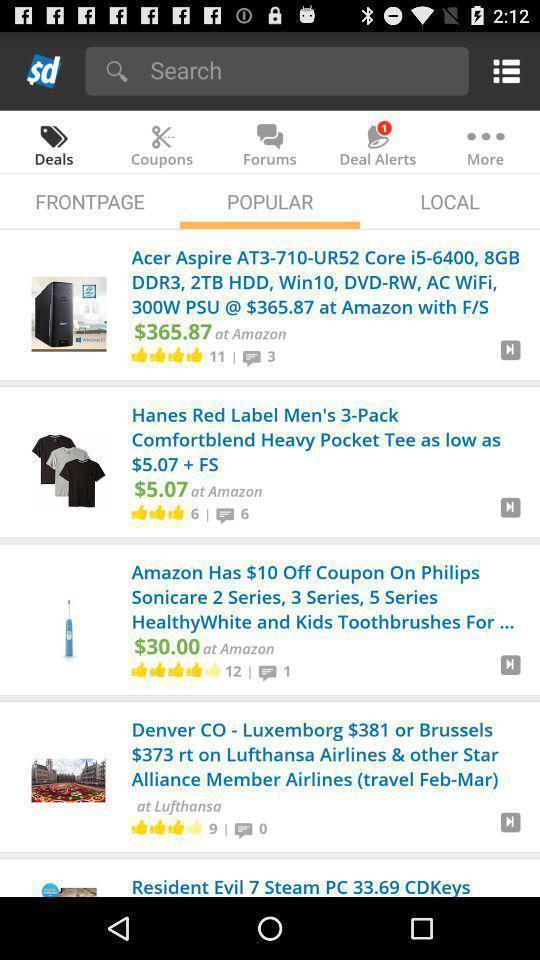What details can you identify in this image? Search page with popular products in shopping app. 